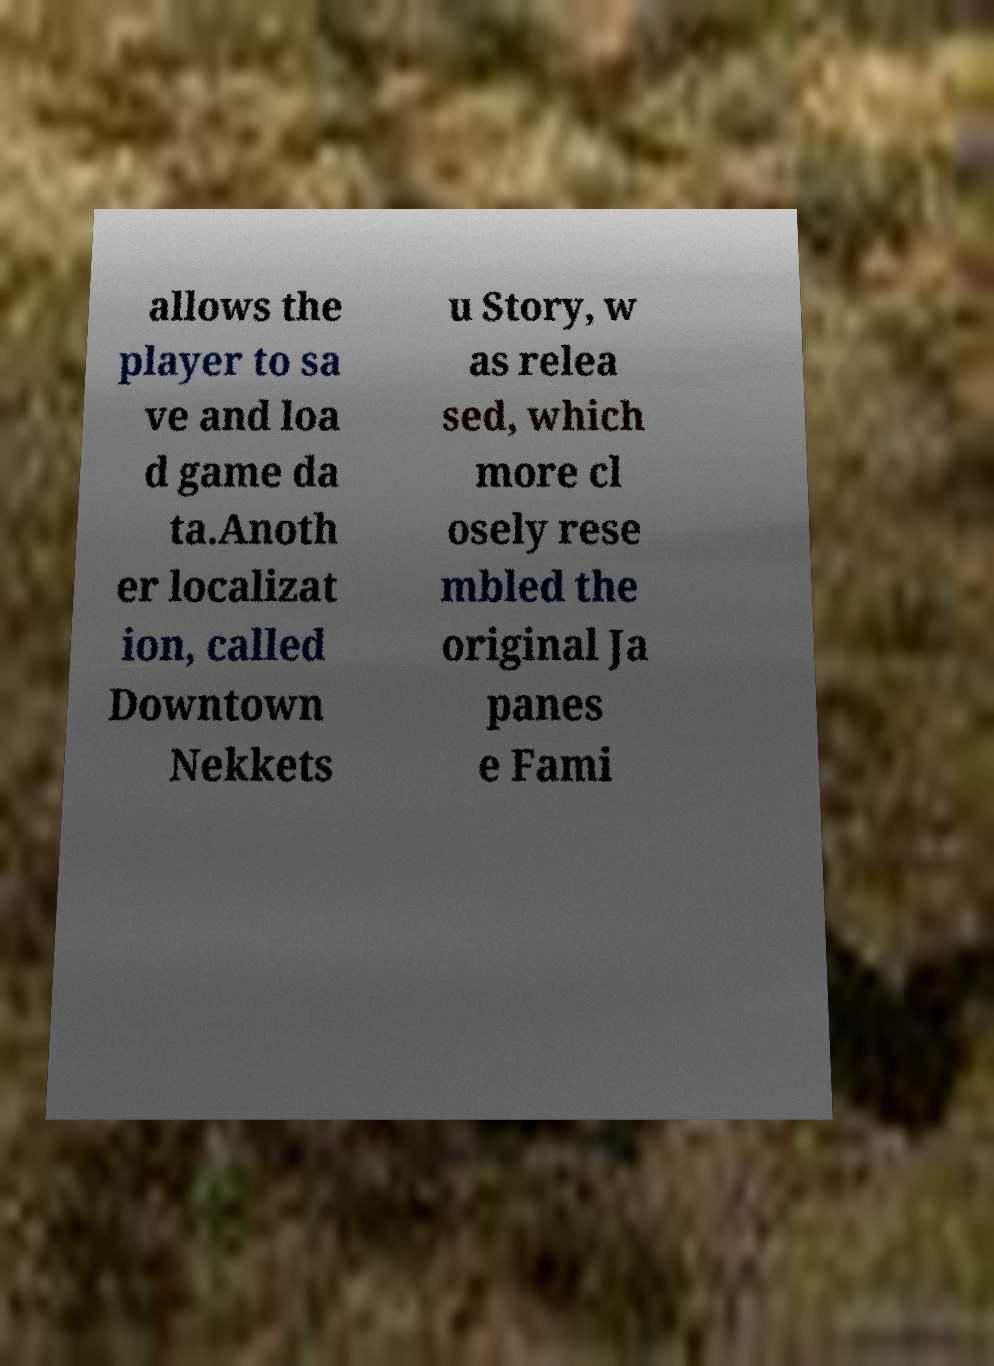Could you extract and type out the text from this image? allows the player to sa ve and loa d game da ta.Anoth er localizat ion, called Downtown Nekkets u Story, w as relea sed, which more cl osely rese mbled the original Ja panes e Fami 